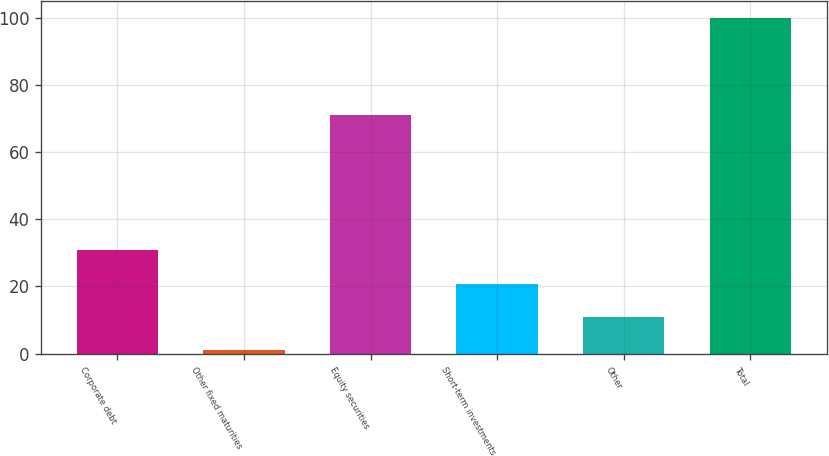<chart> <loc_0><loc_0><loc_500><loc_500><bar_chart><fcel>Corporate debt<fcel>Other fixed maturities<fcel>Equity securities<fcel>Short-term investments<fcel>Other<fcel>Total<nl><fcel>30.7<fcel>1<fcel>71<fcel>20.8<fcel>10.9<fcel>100<nl></chart> 